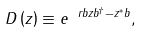Convert formula to latex. <formula><loc_0><loc_0><loc_500><loc_500>D \left ( z \right ) \equiv e ^ { \ r b { z b ^ { \dagger } - z ^ { * } b } } ,</formula> 